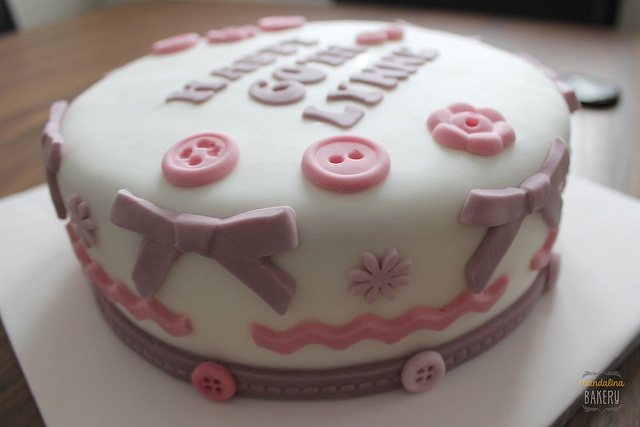Describe the objects in this image and their specific colors. I can see dining table in gray, lightgray, darkgray, and maroon tones and cake in black, gray, lightgray, darkgray, and maroon tones in this image. 